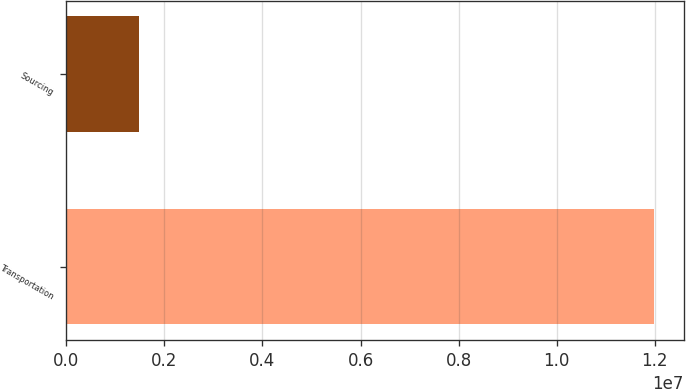Convert chart to OTSL. <chart><loc_0><loc_0><loc_500><loc_500><bar_chart><fcel>Transportation<fcel>Sourcing<nl><fcel>1.19898e+07<fcel>1.4863e+06<nl></chart> 